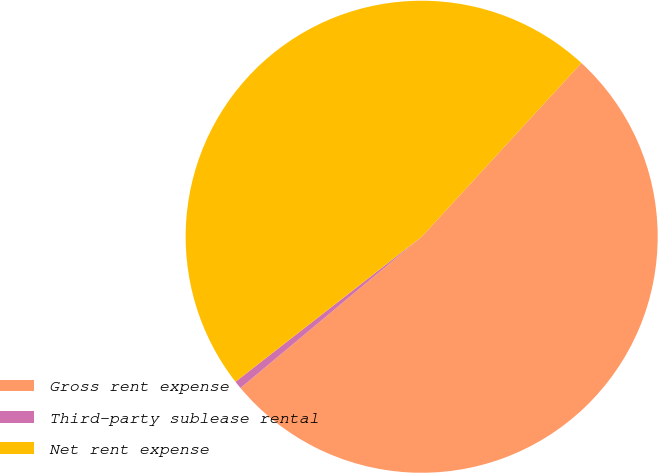Convert chart to OTSL. <chart><loc_0><loc_0><loc_500><loc_500><pie_chart><fcel>Gross rent expense<fcel>Third-party sublease rental<fcel>Net rent expense<nl><fcel>52.1%<fcel>0.54%<fcel>47.36%<nl></chart> 